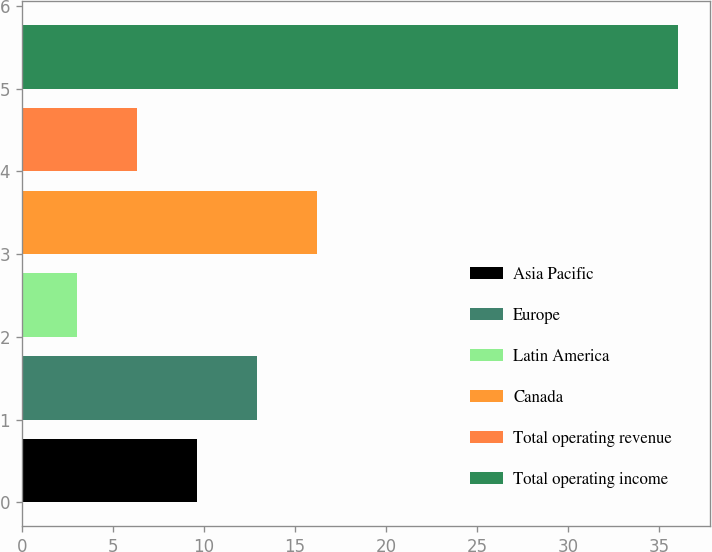<chart> <loc_0><loc_0><loc_500><loc_500><bar_chart><fcel>Asia Pacific<fcel>Europe<fcel>Latin America<fcel>Canada<fcel>Total operating revenue<fcel>Total operating income<nl><fcel>9.6<fcel>12.9<fcel>3<fcel>16.2<fcel>6.3<fcel>36<nl></chart> 